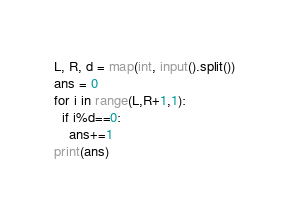<code> <loc_0><loc_0><loc_500><loc_500><_Python_>L, R, d = map(int, input().split())
ans = 0
for i in range(L,R+1,1):
  if i%d==0:
    ans+=1
print(ans)</code> 